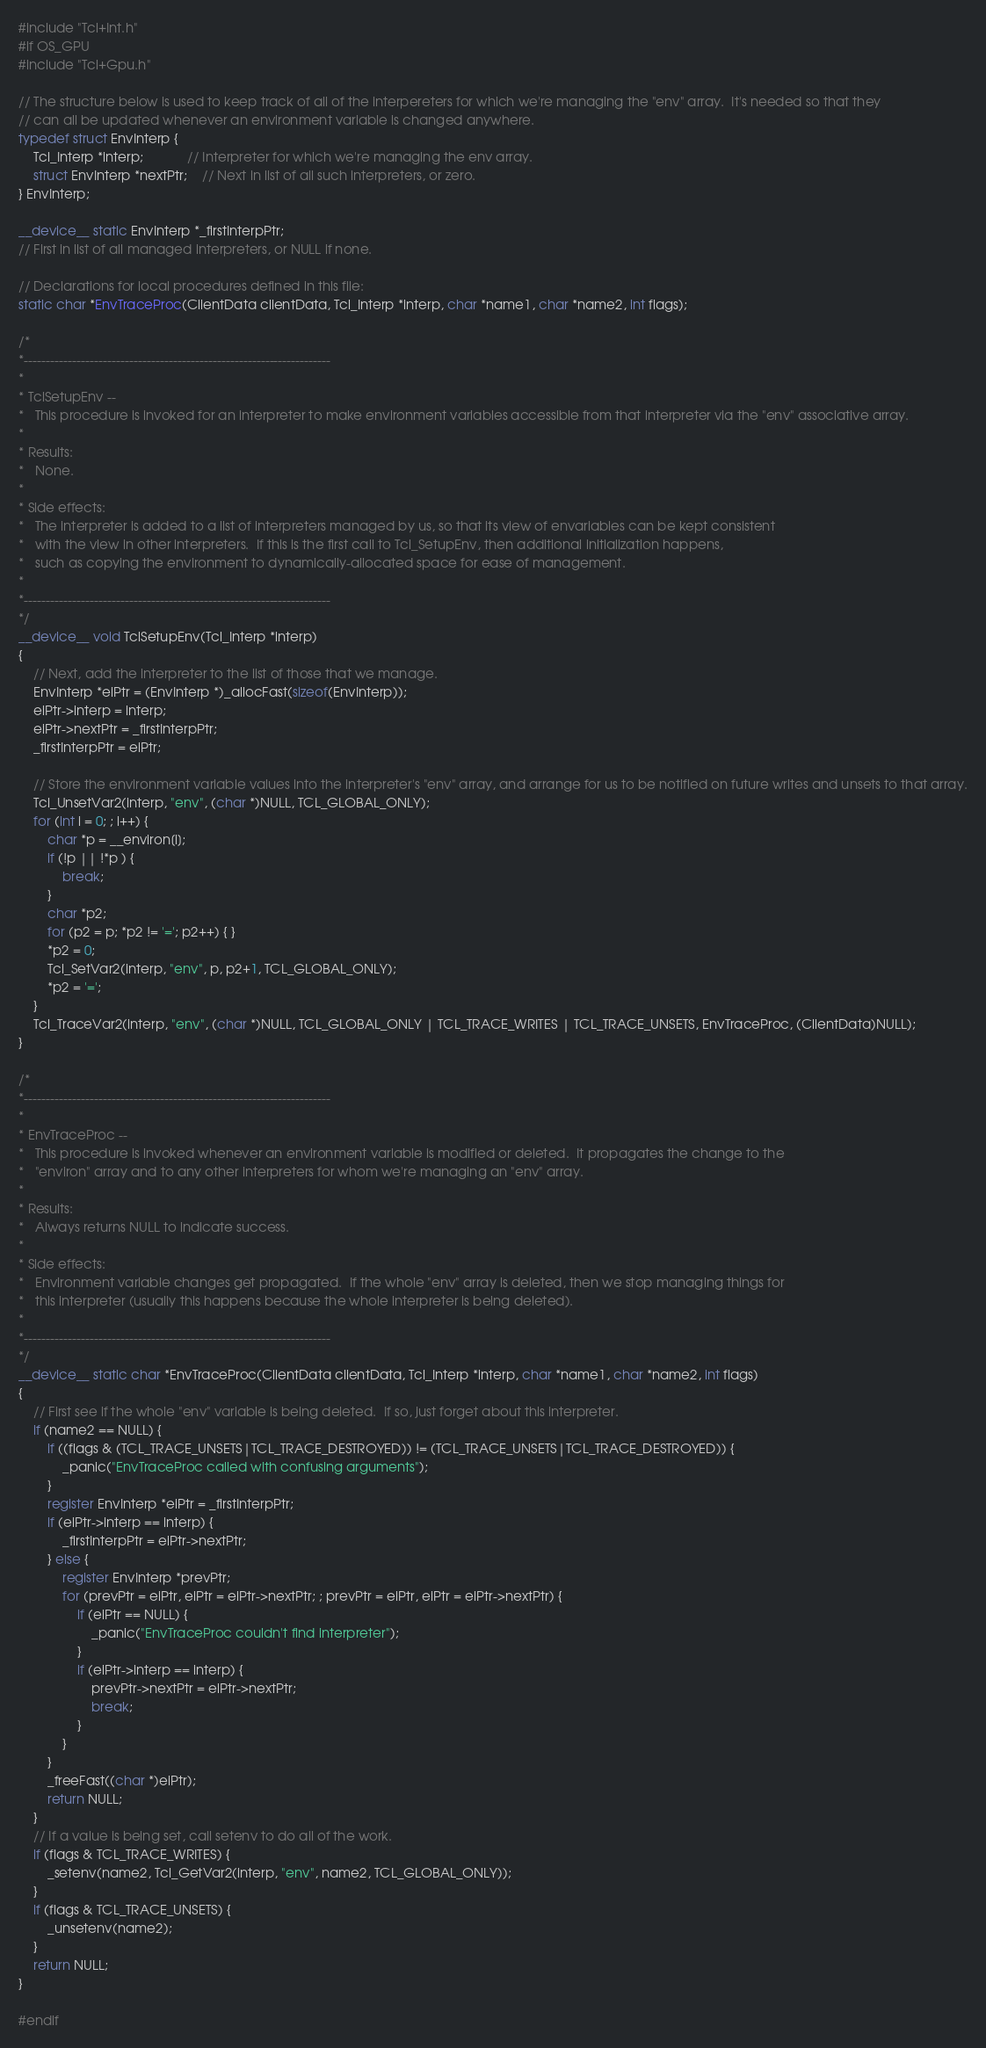<code> <loc_0><loc_0><loc_500><loc_500><_Cuda_>#include "Tcl+Int.h"
#if OS_GPU
#include "Tcl+Gpu.h"

// The structure below is used to keep track of all of the interpereters for which we're managing the "env" array.  It's needed so that they
// can all be updated whenever an environment variable is changed anywhere.
typedef struct EnvInterp {
	Tcl_Interp *interp;			// Interpreter for which we're managing the env array.
	struct EnvInterp *nextPtr;	// Next in list of all such interpreters, or zero.
} EnvInterp;

__device__ static EnvInterp *_firstInterpPtr;
// First in list of all managed interpreters, or NULL if none.

// Declarations for local procedures defined in this file:
static char *EnvTraceProc(ClientData clientData, Tcl_Interp *interp, char *name1, char *name2, int flags);

/*
*----------------------------------------------------------------------
*
* TclSetupEnv --
*	This procedure is invoked for an interpreter to make environment variables accessible from that interpreter via the "env" associative array.
*
* Results:
*	None.
*
* Side effects:
*	The interpreter is added to a list of interpreters managed by us, so that its view of envariables can be kept consistent
*	with the view in other interpreters.  If this is the first call to Tcl_SetupEnv, then additional initialization happens,
*	such as copying the environment to dynamically-allocated space for ease of management.
*
*----------------------------------------------------------------------
*/
__device__ void TclSetupEnv(Tcl_Interp *interp)
{
	// Next, add the interpreter to the list of those that we manage.
	EnvInterp *eiPtr = (EnvInterp *)_allocFast(sizeof(EnvInterp));
	eiPtr->interp = interp;
	eiPtr->nextPtr = _firstInterpPtr;
	_firstInterpPtr = eiPtr;

	// Store the environment variable values into the interpreter's "env" array, and arrange for us to be notified on future writes and unsets to that array.
	Tcl_UnsetVar2(interp, "env", (char *)NULL, TCL_GLOBAL_ONLY);
	for (int i = 0; ; i++) {
		char *p = __environ[i];
		if (!p || !*p ) {
			break;
		}
		char *p2;
		for (p2 = p; *p2 != '='; p2++) { }
		*p2 = 0;
		Tcl_SetVar2(interp, "env", p, p2+1, TCL_GLOBAL_ONLY);
		*p2 = '=';
	}
	Tcl_TraceVar2(interp, "env", (char *)NULL, TCL_GLOBAL_ONLY | TCL_TRACE_WRITES | TCL_TRACE_UNSETS, EnvTraceProc, (ClientData)NULL);
}

/*
*----------------------------------------------------------------------
*
* EnvTraceProc --
*	This procedure is invoked whenever an environment variable is modified or deleted.  It propagates the change to the
*	"environ" array and to any other interpreters for whom we're managing an "env" array.
*
* Results:
*	Always returns NULL to indicate success.
*
* Side effects:
*	Environment variable changes get propagated.  If the whole "env" array is deleted, then we stop managing things for
*	this interpreter (usually this happens because the whole interpreter is being deleted).
*
*----------------------------------------------------------------------
*/
__device__ static char *EnvTraceProc(ClientData clientData, Tcl_Interp *interp, char *name1, char *name2, int flags)
{
	// First see if the whole "env" variable is being deleted.  If so, just forget about this interpreter.
	if (name2 == NULL) {
		if ((flags & (TCL_TRACE_UNSETS|TCL_TRACE_DESTROYED)) != (TCL_TRACE_UNSETS|TCL_TRACE_DESTROYED)) {
			_panic("EnvTraceProc called with confusing arguments");
		}
		register EnvInterp *eiPtr = _firstInterpPtr;
		if (eiPtr->interp == interp) {
			_firstInterpPtr = eiPtr->nextPtr;
		} else {
			register EnvInterp *prevPtr;
			for (prevPtr = eiPtr, eiPtr = eiPtr->nextPtr; ; prevPtr = eiPtr, eiPtr = eiPtr->nextPtr) {
				if (eiPtr == NULL) {
					_panic("EnvTraceProc couldn't find interpreter");
				}
				if (eiPtr->interp == interp) {
					prevPtr->nextPtr = eiPtr->nextPtr;
					break;
				}
			}
		}
		_freeFast((char *)eiPtr);
		return NULL;
	}
	// If a value is being set, call setenv to do all of the work.
	if (flags & TCL_TRACE_WRITES) {
		_setenv(name2, Tcl_GetVar2(interp, "env", name2, TCL_GLOBAL_ONLY));
	}
	if (flags & TCL_TRACE_UNSETS) {
		_unsetenv(name2);
	}
	return NULL;
}

#endif</code> 